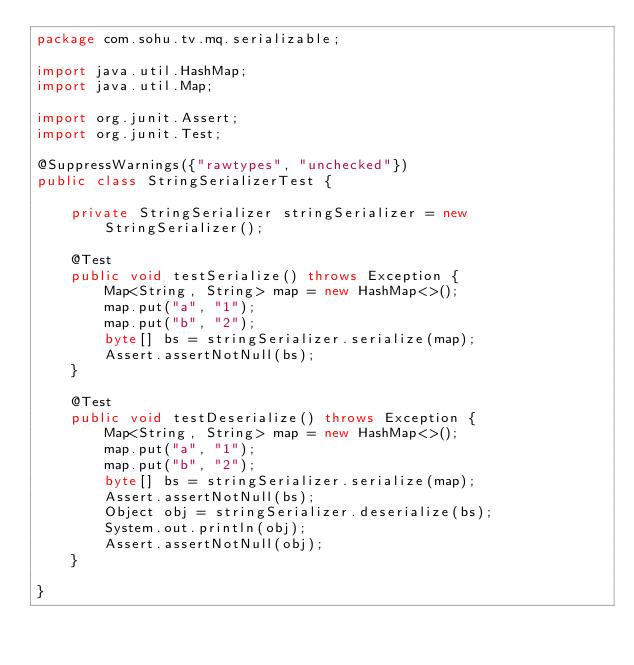<code> <loc_0><loc_0><loc_500><loc_500><_Java_>package com.sohu.tv.mq.serializable;

import java.util.HashMap;
import java.util.Map;

import org.junit.Assert;
import org.junit.Test;

@SuppressWarnings({"rawtypes", "unchecked"})
public class StringSerializerTest {

    private StringSerializer stringSerializer = new StringSerializer();

    @Test
    public void testSerialize() throws Exception {
        Map<String, String> map = new HashMap<>();
        map.put("a", "1");
        map.put("b", "2");
        byte[] bs = stringSerializer.serialize(map);
        Assert.assertNotNull(bs);
    }

    @Test
    public void testDeserialize() throws Exception {
        Map<String, String> map = new HashMap<>();
        map.put("a", "1");
        map.put("b", "2");
        byte[] bs = stringSerializer.serialize(map);
        Assert.assertNotNull(bs);
        Object obj = stringSerializer.deserialize(bs);
        System.out.println(obj);
        Assert.assertNotNull(obj);
    }

}
</code> 